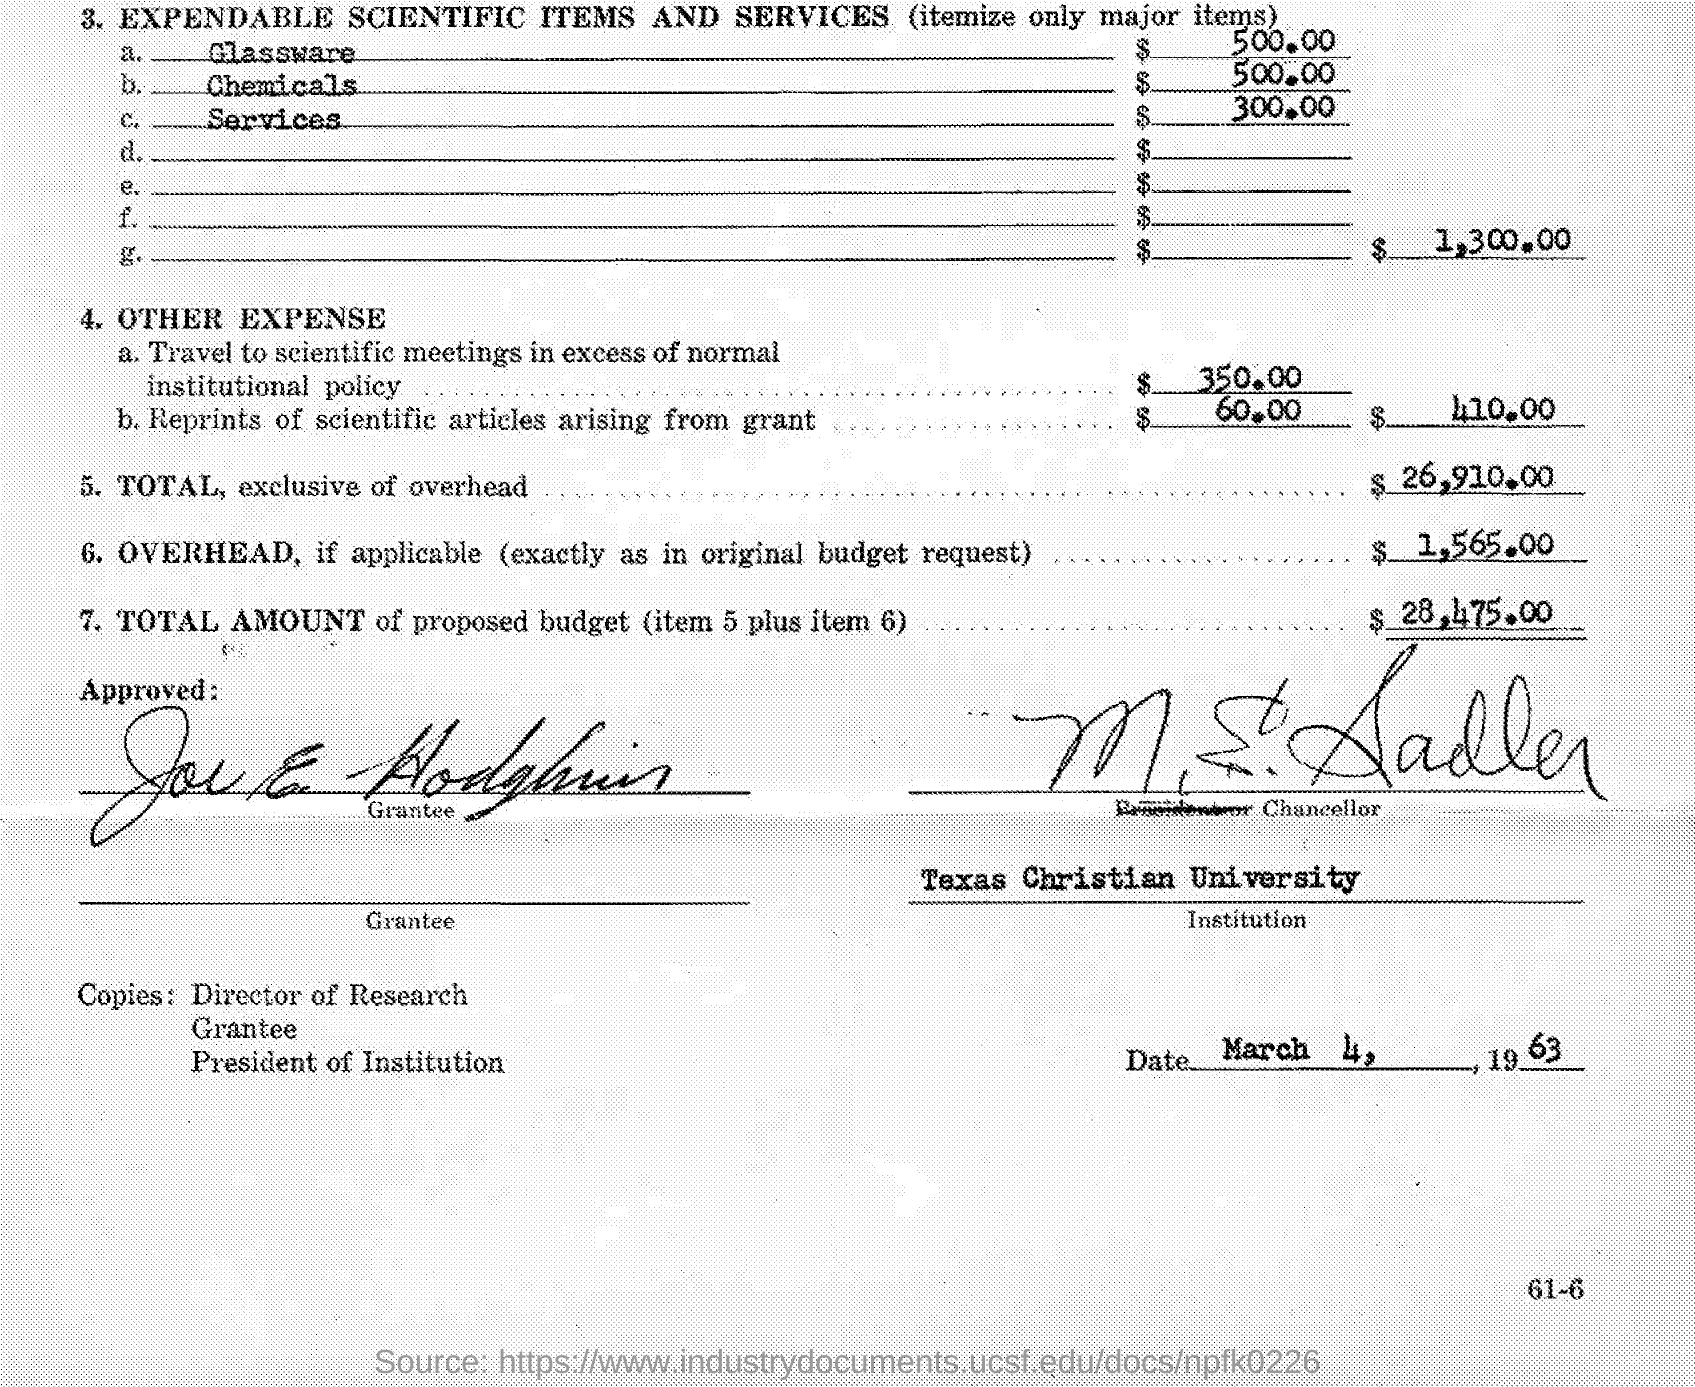Point out several critical features in this image. Texas Christian University is mentioned. The document is dated March 4, 1963. 